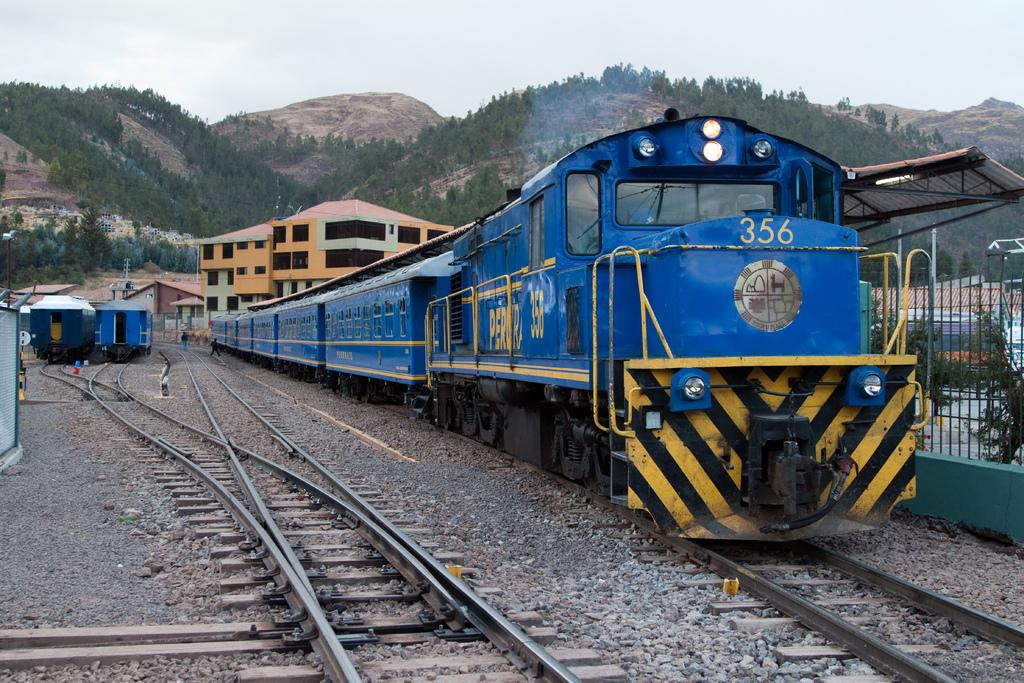<image>
Present a compact description of the photo's key features. The blue train engine number 356 is pulling six rail cars behind it. 